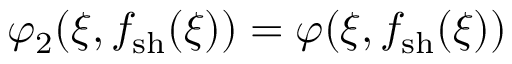Convert formula to latex. <formula><loc_0><loc_0><loc_500><loc_500>\varphi _ { 2 } ( \xi , f _ { s h } ( \xi ) ) = \varphi ( \xi , f _ { s h } ( \xi ) )</formula> 